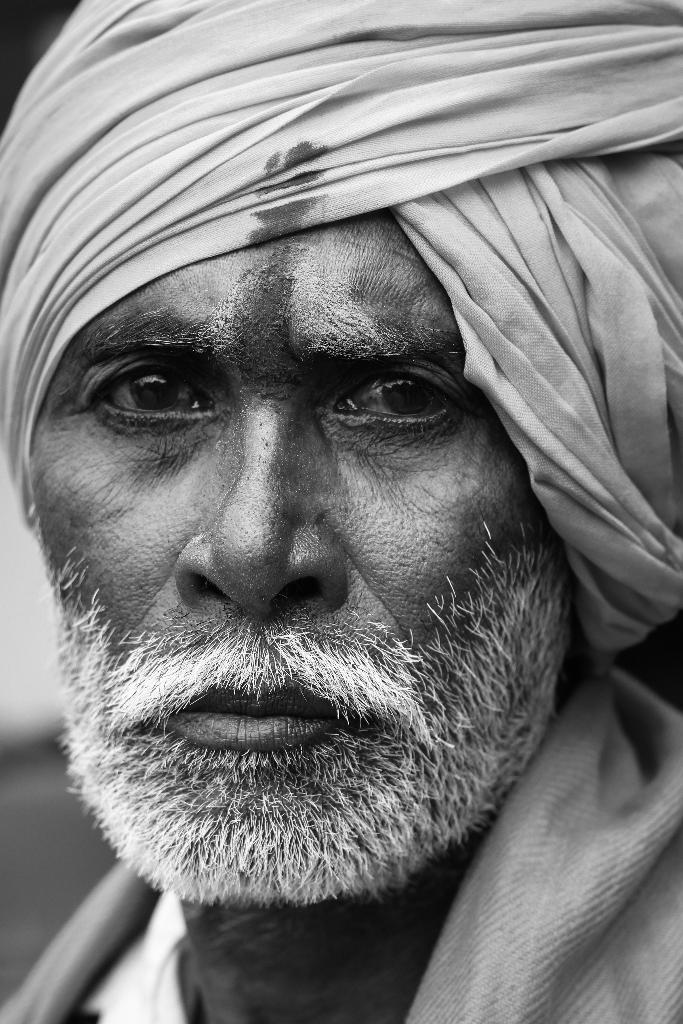What is the color scheme of the image? The image is black and white. Can you describe the person in the image? There is a man in the image. What is the man holding in the image? The man is holding white bread. What type of copper material is the man using to hold the bottle in the image? There is no copper material or bottle present in the image. Can you describe the scarecrow in the image? There is no scarecrow present in the image. 